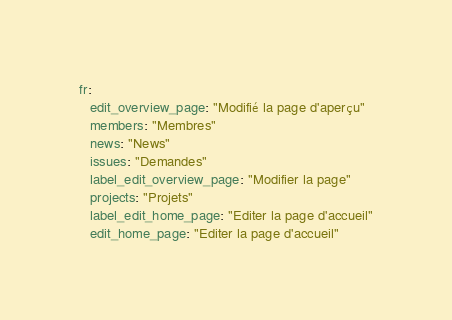Convert code to text. <code><loc_0><loc_0><loc_500><loc_500><_YAML_>
fr:
   edit_overview_page: "Modifié la page d'aperçu"
   members: "Membres"
   news: "News"
   issues: "Demandes"
   label_edit_overview_page: "Modifier la page"
   projects: "Projets"
   label_edit_home_page: "Editer la page d'accueil"
   edit_home_page: "Editer la page d'accueil"
</code> 